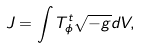Convert formula to latex. <formula><loc_0><loc_0><loc_500><loc_500>J = \int T _ { \phi } ^ { t } \sqrt { - g } d V ,</formula> 